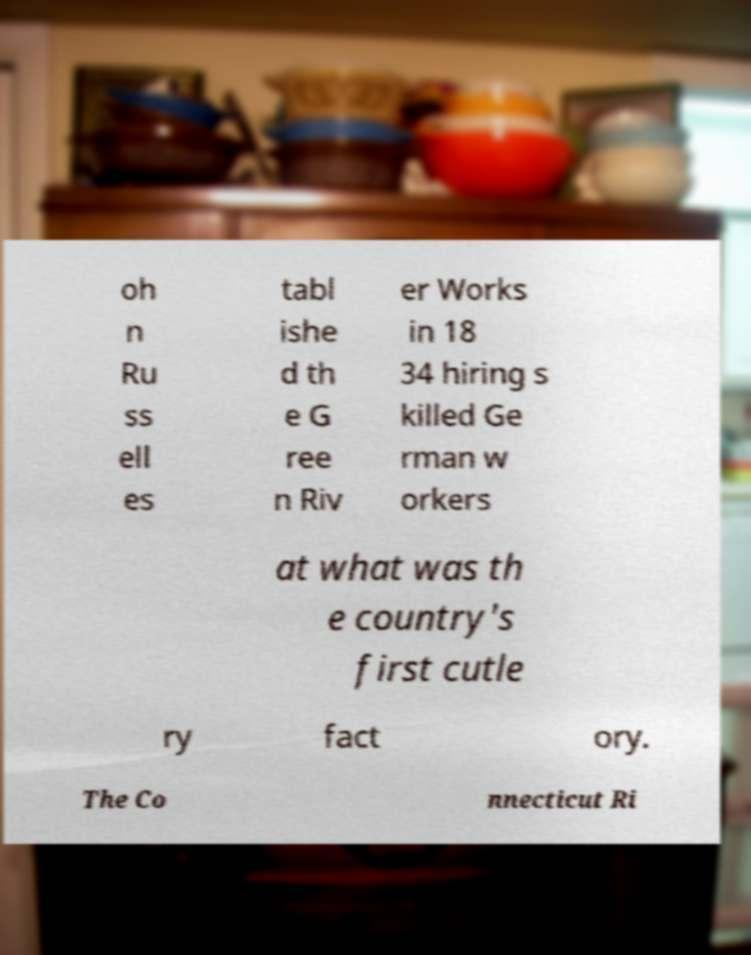Could you assist in decoding the text presented in this image and type it out clearly? oh n Ru ss ell es tabl ishe d th e G ree n Riv er Works in 18 34 hiring s killed Ge rman w orkers at what was th e country's first cutle ry fact ory. The Co nnecticut Ri 